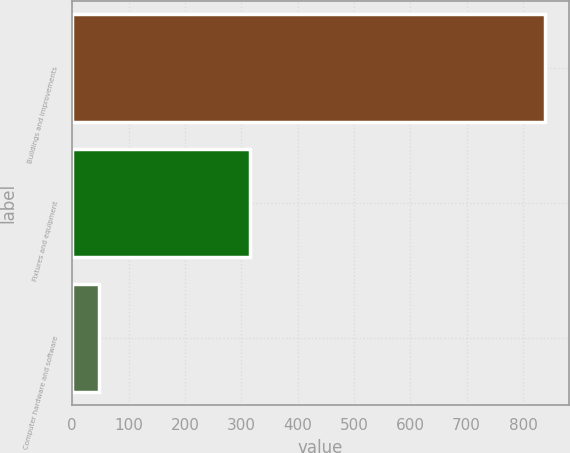Convert chart. <chart><loc_0><loc_0><loc_500><loc_500><bar_chart><fcel>Buildings and improvements<fcel>Fixtures and equipment<fcel>Computer hardware and software<nl><fcel>839<fcel>315<fcel>47<nl></chart> 